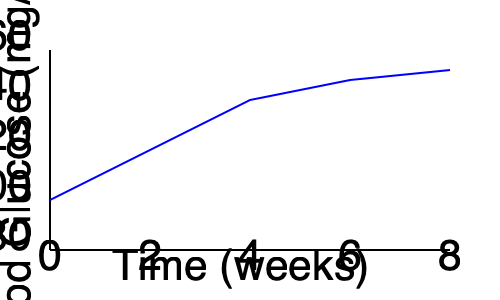Analyze the trend of blood glucose levels over time for a patient on a ketogenic diet as shown in the graph. What is the approximate percentage decrease in blood glucose levels from week 0 to week 8, and what physiological mechanism might explain this trend? To answer this question, we need to follow these steps:

1. Identify the initial and final blood glucose levels:
   - Week 0: Approximately 140 mg/dL
   - Week 8: Approximately 90 mg/dL

2. Calculate the percentage decrease:
   Percentage decrease = $\frac{\text{Initial value} - \text{Final value}}{\text{Initial value}} \times 100\%$
   
   $= \frac{140 - 90}{140} \times 100\%$
   $= \frac{50}{140} \times 100\%$
   $\approx 35.7\%$

3. Explain the physiological mechanism:
   The decrease in blood glucose levels can be attributed to the ketogenic diet's effect on insulin sensitivity and glucose metabolism. The ketogenic diet is characterized by very low carbohydrate intake, moderate protein, and high fat consumption. This macronutrient composition leads to:

   a) Reduced glucose intake, lowering the overall blood glucose levels.
   b) Decreased insulin secretion due to lower carbohydrate intake.
   c) Improved insulin sensitivity in tissues, enhancing glucose uptake and utilization.
   d) Increased production of ketone bodies, which become the primary fuel source instead of glucose.
   e) Upregulation of gluconeogenesis to maintain minimal necessary glucose levels for certain tissues.

   These combined effects result in a gradual decrease in fasting blood glucose levels as the body adapts to using ketones for energy and becomes more efficient at regulating glucose homeostasis.
Answer: Approximately 35.7% decrease; improved insulin sensitivity and shift to ketone metabolism. 